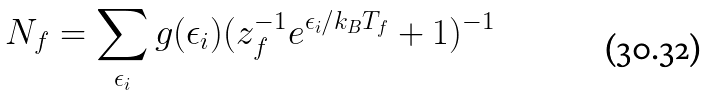<formula> <loc_0><loc_0><loc_500><loc_500>N _ { f } = \sum _ { \epsilon _ { i } } g ( \epsilon _ { i } ) ( z _ { f } ^ { - 1 } e ^ { \epsilon _ { i } / k _ { B } T _ { f } } + 1 ) ^ { - 1 }</formula> 